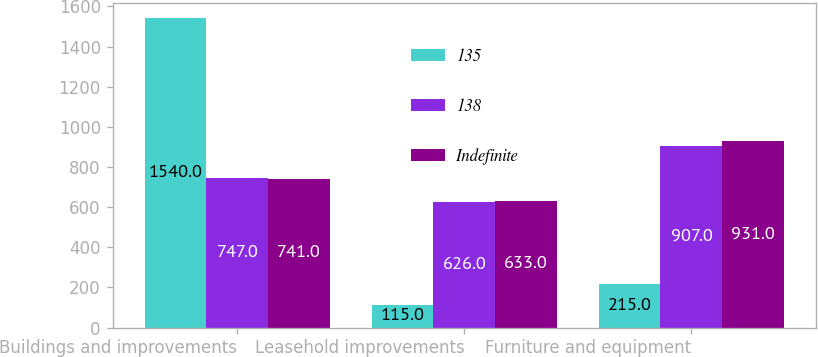<chart> <loc_0><loc_0><loc_500><loc_500><stacked_bar_chart><ecel><fcel>Buildings and improvements<fcel>Leasehold improvements<fcel>Furniture and equipment<nl><fcel>135<fcel>1540<fcel>115<fcel>215<nl><fcel>138<fcel>747<fcel>626<fcel>907<nl><fcel>Indefinite<fcel>741<fcel>633<fcel>931<nl></chart> 